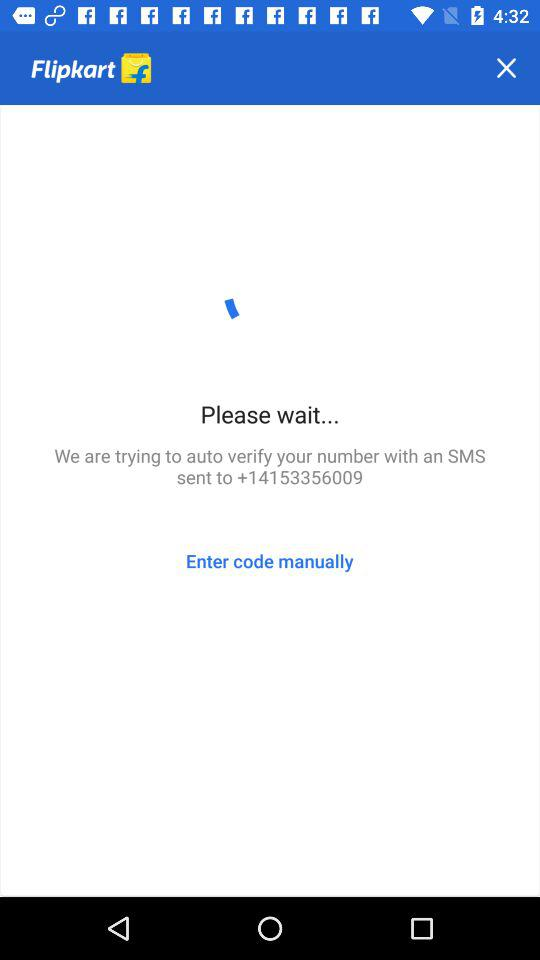To which number is the SMS sent for verification? The number is +14153356009. 